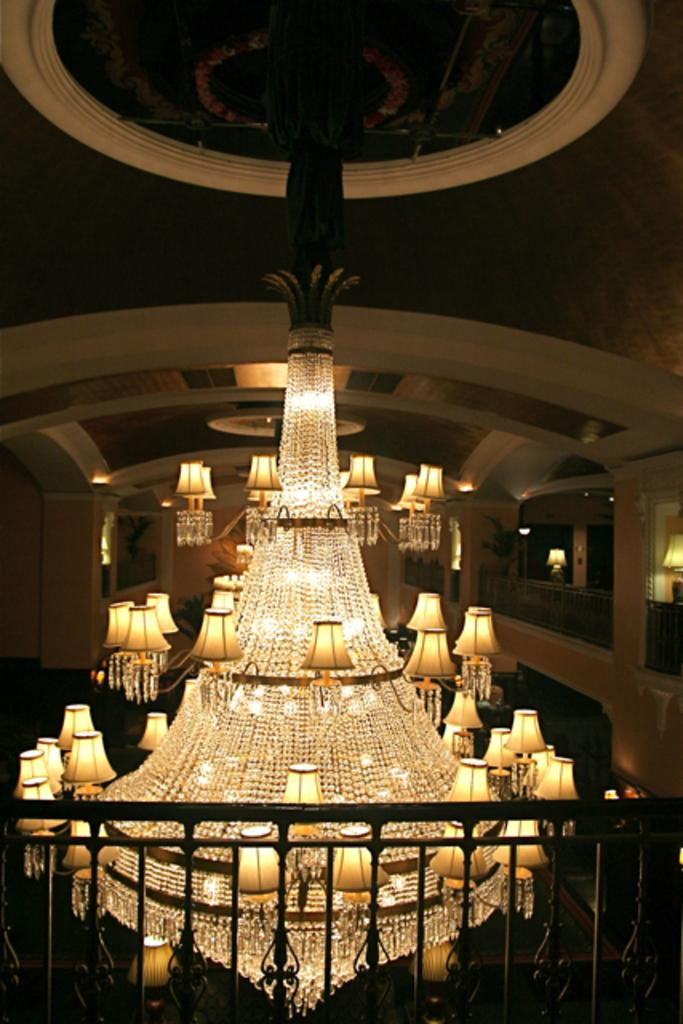What type of structure can be seen in the image? There is a fence in the image. What type of lighting fixture is present in the image? There is a chandelier in the image. What can be seen in the background of the image? In the background, there are lights visible, a lamp, a wall, and fences. How does the wax drip from the chandelier in the image? There is no wax dripping from the chandelier in the image. What type of attention does the fence demand in the image? The fence does not demand any specific type of attention in the image; it is simply a part of the scene. 